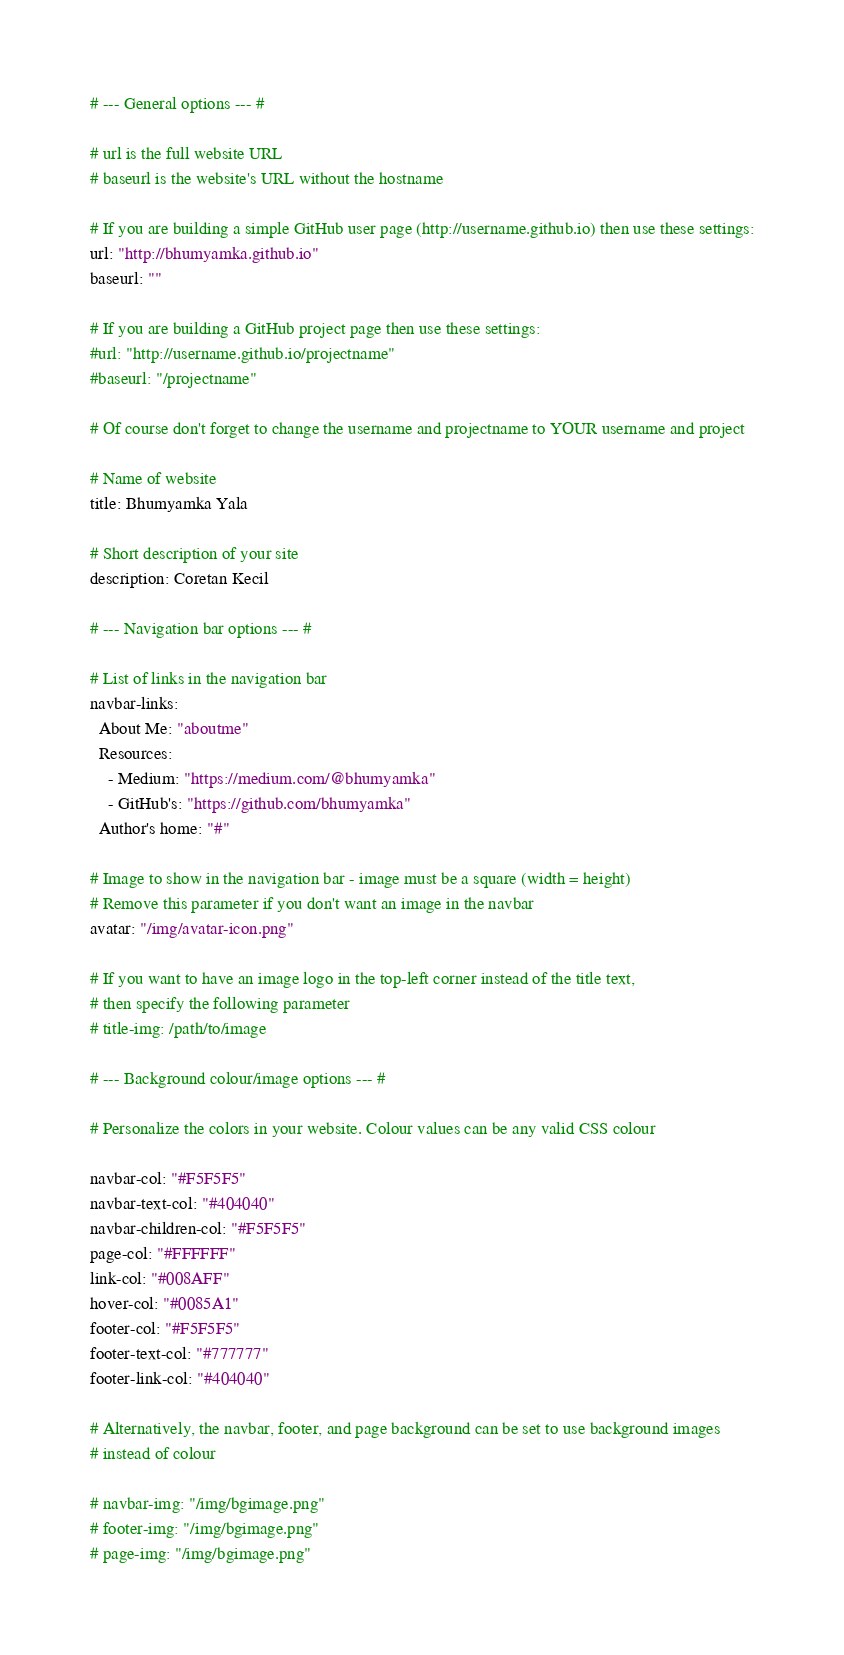<code> <loc_0><loc_0><loc_500><loc_500><_YAML_># --- General options --- #

# url is the full website URL
# baseurl is the website's URL without the hostname

# If you are building a simple GitHub user page (http://username.github.io) then use these settings:
url: "http://bhumyamka.github.io"
baseurl: ""

# If you are building a GitHub project page then use these settings:
#url: "http://username.github.io/projectname"
#baseurl: "/projectname"

# Of course don't forget to change the username and projectname to YOUR username and project

# Name of website
title: Bhumyamka Yala 

# Short description of your site
description: Coretan Kecil

# --- Navigation bar options --- #

# List of links in the navigation bar
navbar-links:
  About Me: "aboutme"
  Resources:
    - Medium: "https://medium.com/@bhumyamka"
    - GitHub's: "https://github.com/bhumyamka"
  Author's home: "#"

# Image to show in the navigation bar - image must be a square (width = height)
# Remove this parameter if you don't want an image in the navbar
avatar: "/img/avatar-icon.png"

# If you want to have an image logo in the top-left corner instead of the title text,
# then specify the following parameter
# title-img: /path/to/image

# --- Background colour/image options --- #

# Personalize the colors in your website. Colour values can be any valid CSS colour

navbar-col: "#F5F5F5"
navbar-text-col: "#404040"
navbar-children-col: "#F5F5F5"
page-col: "#FFFFFF"
link-col: "#008AFF"
hover-col: "#0085A1"
footer-col: "#F5F5F5"
footer-text-col: "#777777"
footer-link-col: "#404040"

# Alternatively, the navbar, footer, and page background can be set to use background images
# instead of colour

# navbar-img: "/img/bgimage.png"
# footer-img: "/img/bgimage.png"
# page-img: "/img/bgimage.png"
</code> 